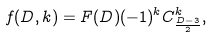<formula> <loc_0><loc_0><loc_500><loc_500>f ( D , k ) = F ( D ) ( - 1 ) ^ { k } C ^ { k } _ { \frac { D - 3 } { 2 } } ,</formula> 